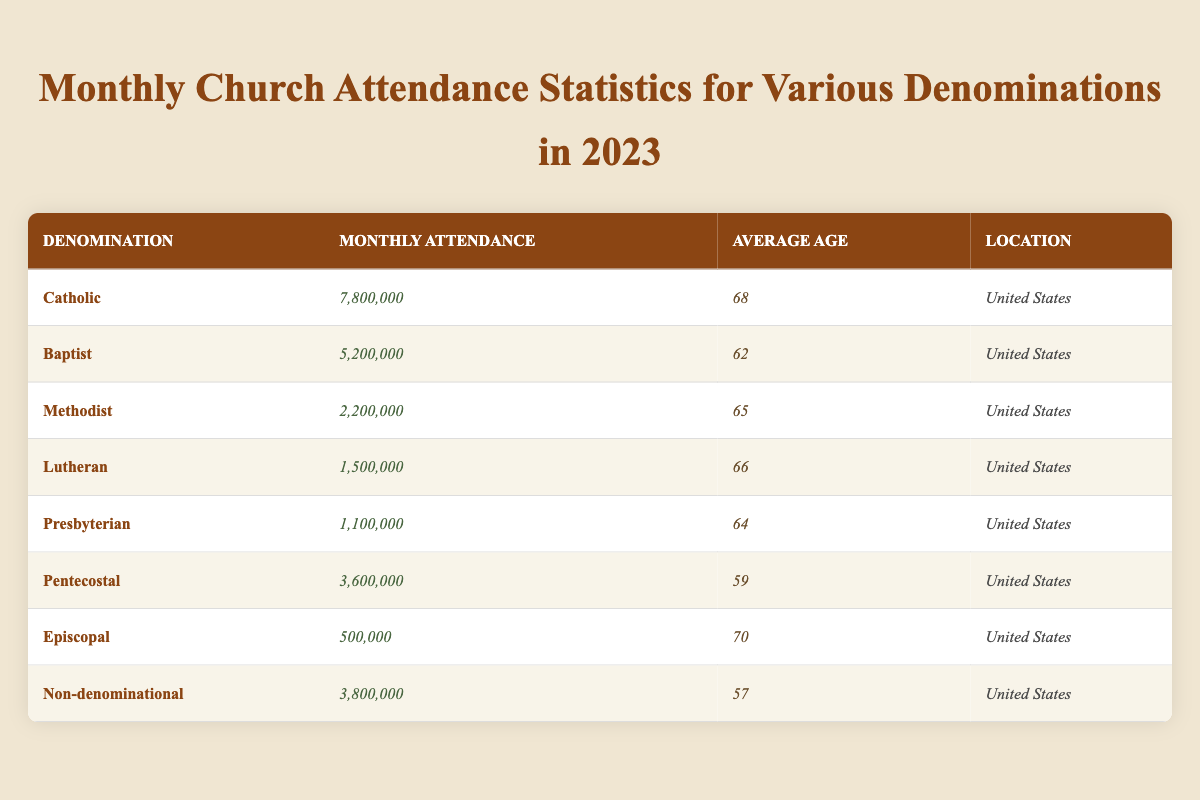What is the monthly attendance for the Catholic denomination? According to the table, the monthly attendance for the Catholic denomination is listed as 7,800,000.
Answer: 7,800,000 Which denomination has the lowest monthly attendance? From the table, the Episcopal denomination has the lowest monthly attendance, with 500,000 recorded.
Answer: 500,000 What is the average age of attendees for the Baptist denomination? The average age of attendees for the Baptist denomination, as per the table, is noted to be 62.
Answer: 62 How many more people attend Catholic services than Episcopal services? The table shows Catholic monthly attendance as 7,800,000 and Episcopal as 500,000. The difference is 7,800,000 - 500,000 = 7,300,000.
Answer: 7,300,000 Which denominations have an average age of 65 or older? By checking the average age in the table, the Catholic (68), Lutheran (66), Methodist (65), and Episcopal (70) denominations meet this criterion.
Answer: Catholic, Lutheran, Methodist, Episcopal What is the combined monthly attendance for Pentecostal and Non-denominational churches? The monthly attendance for Pentecostal is 3,600,000 and for Non-denominational is 3,800,000. The combined attendance is 3,600,000 + 3,800,000 = 7,400,000.
Answer: 7,400,000 True or False: The average age of attendees at Lutheran churches is higher than those at Baptist churches. From the table, the average age for Lutheran is 66 and for Baptist is 62. Since 66 is greater than 62, the statement is true.
Answer: True What is the difference in average age between Pentecostal and Presbyterians? The average age for Pentecostal is 59 and for Presbyterian is 64. The difference is 64 - 59 = 5.
Answer: 5 If you add the monthly attendances for Non-denominational and Methodist churches, what is the total? The monthly attendance for Non-denominational is 3,800,000 and for Methodist is 2,200,000. Adding these gives 3,800,000 + 2,200,000 = 6,000,000.
Answer: 6,000,000 Which denomination has a monthly attendance above 5 million? The denominations with monthly attendance above 5 million are Catholic (7,800,000) and Baptist (5,200,000) according to the table.
Answer: Catholic, Baptist 